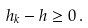<formula> <loc_0><loc_0><loc_500><loc_500>h _ { k } - h \geq 0 \, .</formula> 